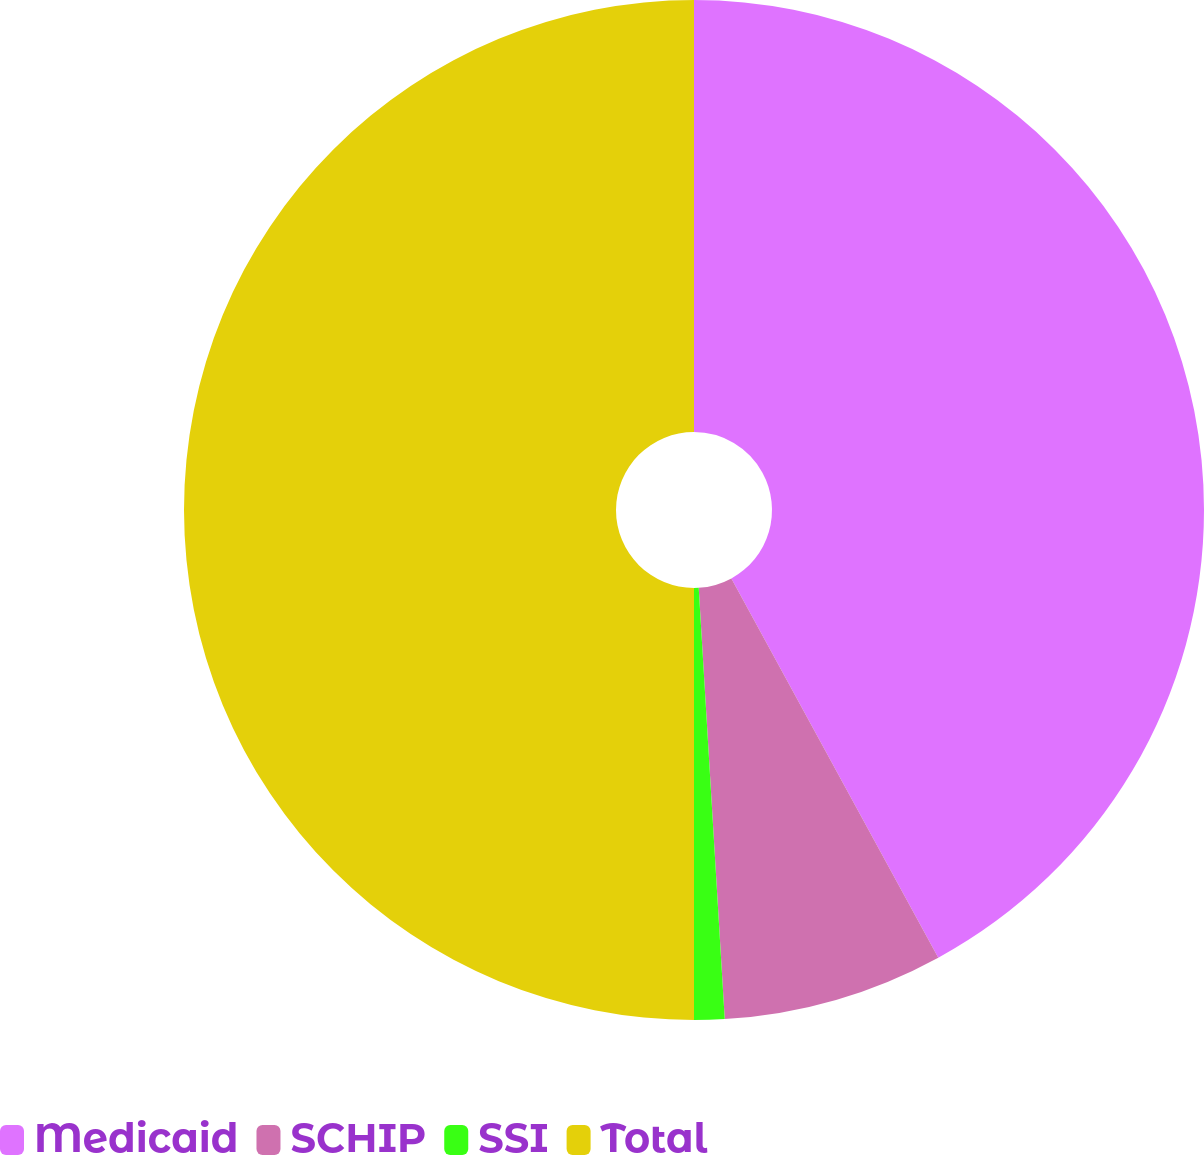Convert chart to OTSL. <chart><loc_0><loc_0><loc_500><loc_500><pie_chart><fcel>Medicaid<fcel>SCHIP<fcel>SSI<fcel>Total<nl><fcel>42.05%<fcel>6.99%<fcel>0.96%<fcel>50.0%<nl></chart> 